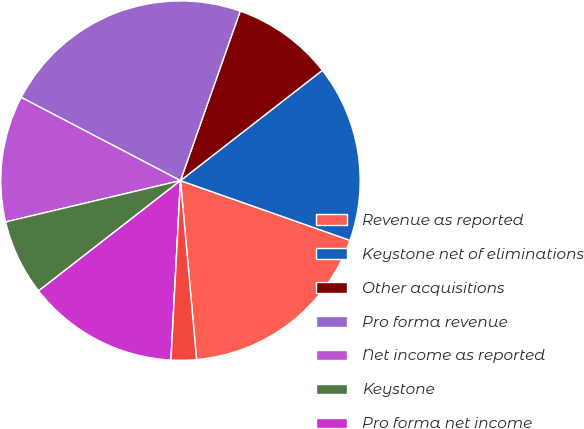Convert chart. <chart><loc_0><loc_0><loc_500><loc_500><pie_chart><fcel>Revenue as reported<fcel>Keystone net of eliminations<fcel>Other acquisitions<fcel>Pro forma revenue<fcel>Net income as reported<fcel>Keystone<fcel>Pro forma net income<fcel>As reported<fcel>Pro forma earnings per<nl><fcel>18.18%<fcel>15.91%<fcel>9.09%<fcel>22.73%<fcel>11.36%<fcel>6.82%<fcel>13.64%<fcel>0.0%<fcel>2.27%<nl></chart> 